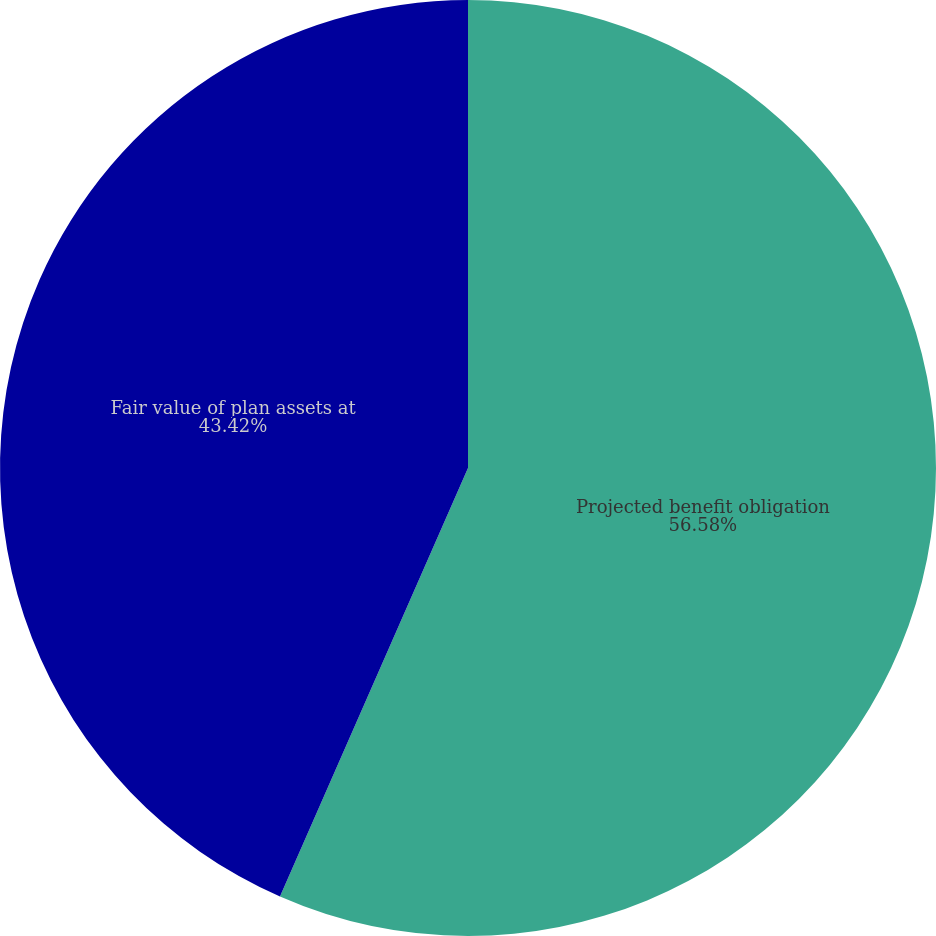Convert chart to OTSL. <chart><loc_0><loc_0><loc_500><loc_500><pie_chart><fcel>Projected benefit obligation<fcel>Fair value of plan assets at<nl><fcel>56.58%<fcel>43.42%<nl></chart> 